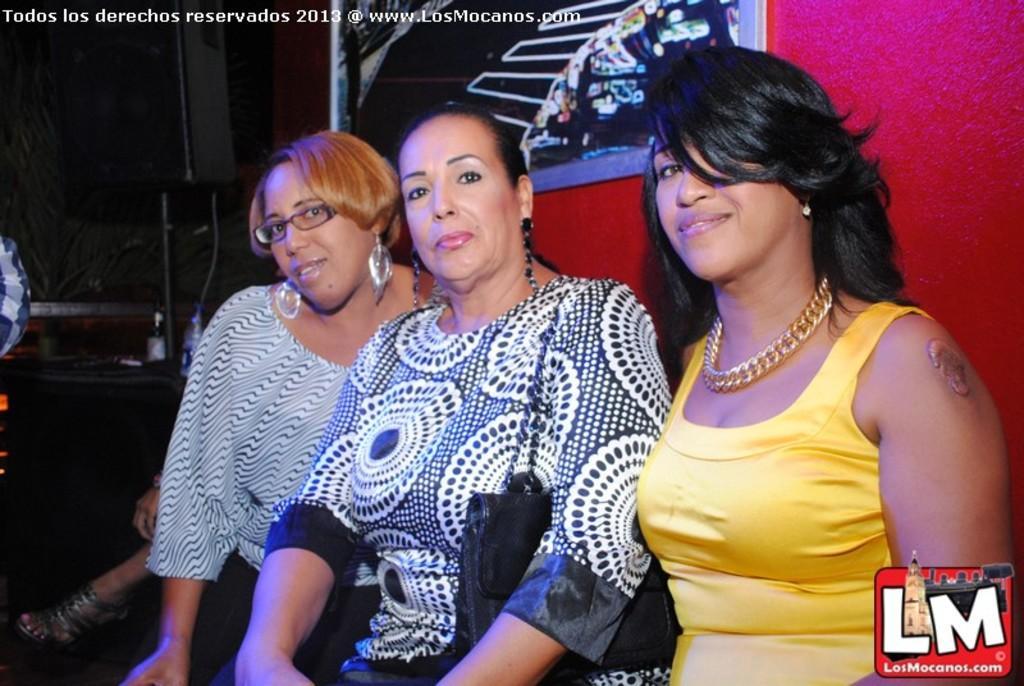In one or two sentences, can you explain what this image depicts? In this image, I can see three women. In the bottom left side of the image, I can see a leg and a hand of a person. In the background, there are bottles, a speaker with a stand and few other objects. Behind the women, I can see a photo frame attached to the wall. At the top of the image and in the bottom right corner of the image, I can see the watermarks. 